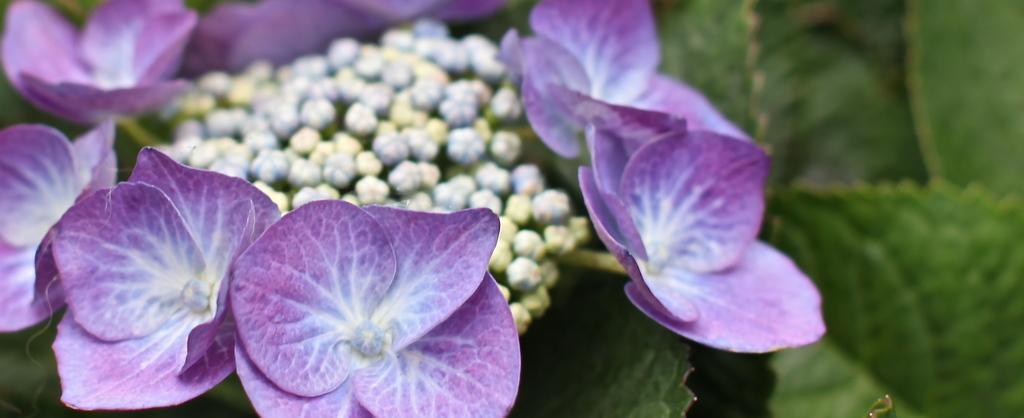Please provide a concise description of this image. In the picture we can see some flowers which are in violet and white color and there are leaves which are in green color. 